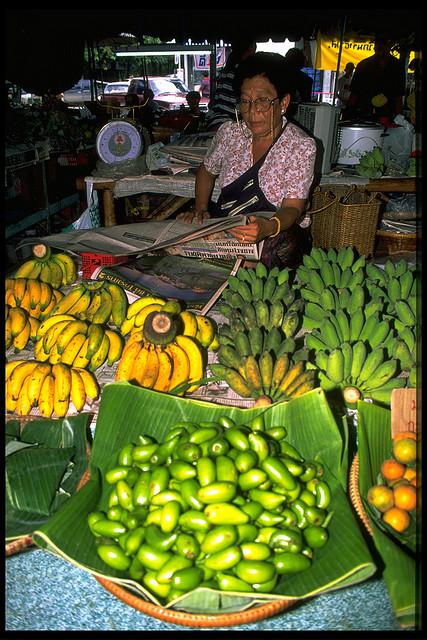What color is the fruit on the left?
Give a very brief answer. Yellow. Who is in the background?
Keep it brief. Woman. IS there a scale beside the woman?
Quick response, please. Yes. 